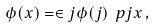Convert formula to latex. <formula><loc_0><loc_0><loc_500><loc_500>\phi ( x ) = \in j \phi ( j ) \ p j x \, ,</formula> 